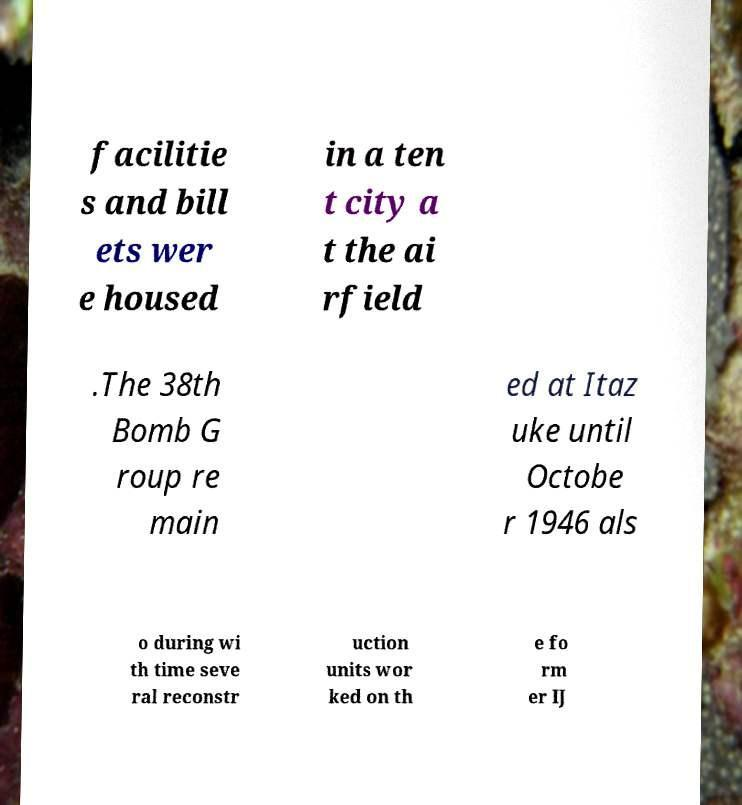Could you extract and type out the text from this image? facilitie s and bill ets wer e housed in a ten t city a t the ai rfield .The 38th Bomb G roup re main ed at Itaz uke until Octobe r 1946 als o during wi th time seve ral reconstr uction units wor ked on th e fo rm er IJ 